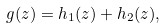Convert formula to latex. <formula><loc_0><loc_0><loc_500><loc_500>g ( z ) = h _ { 1 } ( z ) + h _ { 2 } ( z ) ,</formula> 